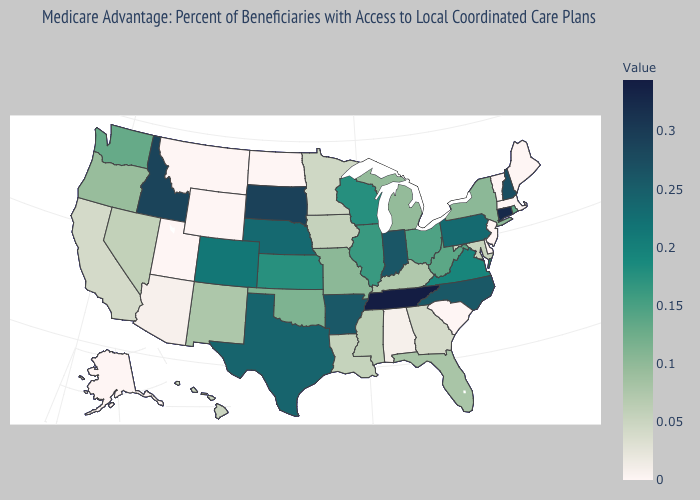Does Massachusetts have the lowest value in the USA?
Give a very brief answer. Yes. Does Kentucky have a higher value than Delaware?
Answer briefly. Yes. Which states have the lowest value in the South?
Write a very short answer. Delaware, South Carolina. Does South Carolina have the lowest value in the South?
Be succinct. Yes. Which states have the lowest value in the West?
Answer briefly. Alaska, Montana, Utah, Wyoming. Does Maine have the highest value in the Northeast?
Be succinct. No. 